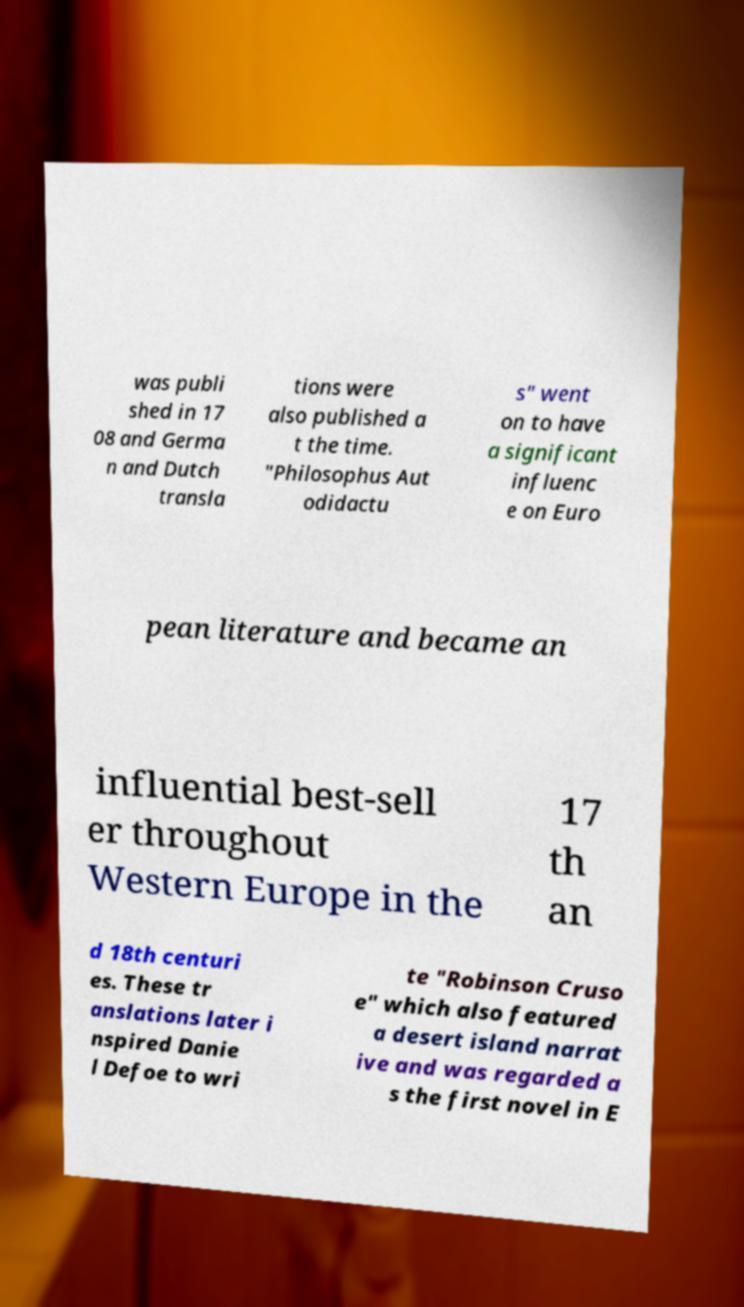For documentation purposes, I need the text within this image transcribed. Could you provide that? was publi shed in 17 08 and Germa n and Dutch transla tions were also published a t the time. "Philosophus Aut odidactu s" went on to have a significant influenc e on Euro pean literature and became an influential best-sell er throughout Western Europe in the 17 th an d 18th centuri es. These tr anslations later i nspired Danie l Defoe to wri te "Robinson Cruso e" which also featured a desert island narrat ive and was regarded a s the first novel in E 